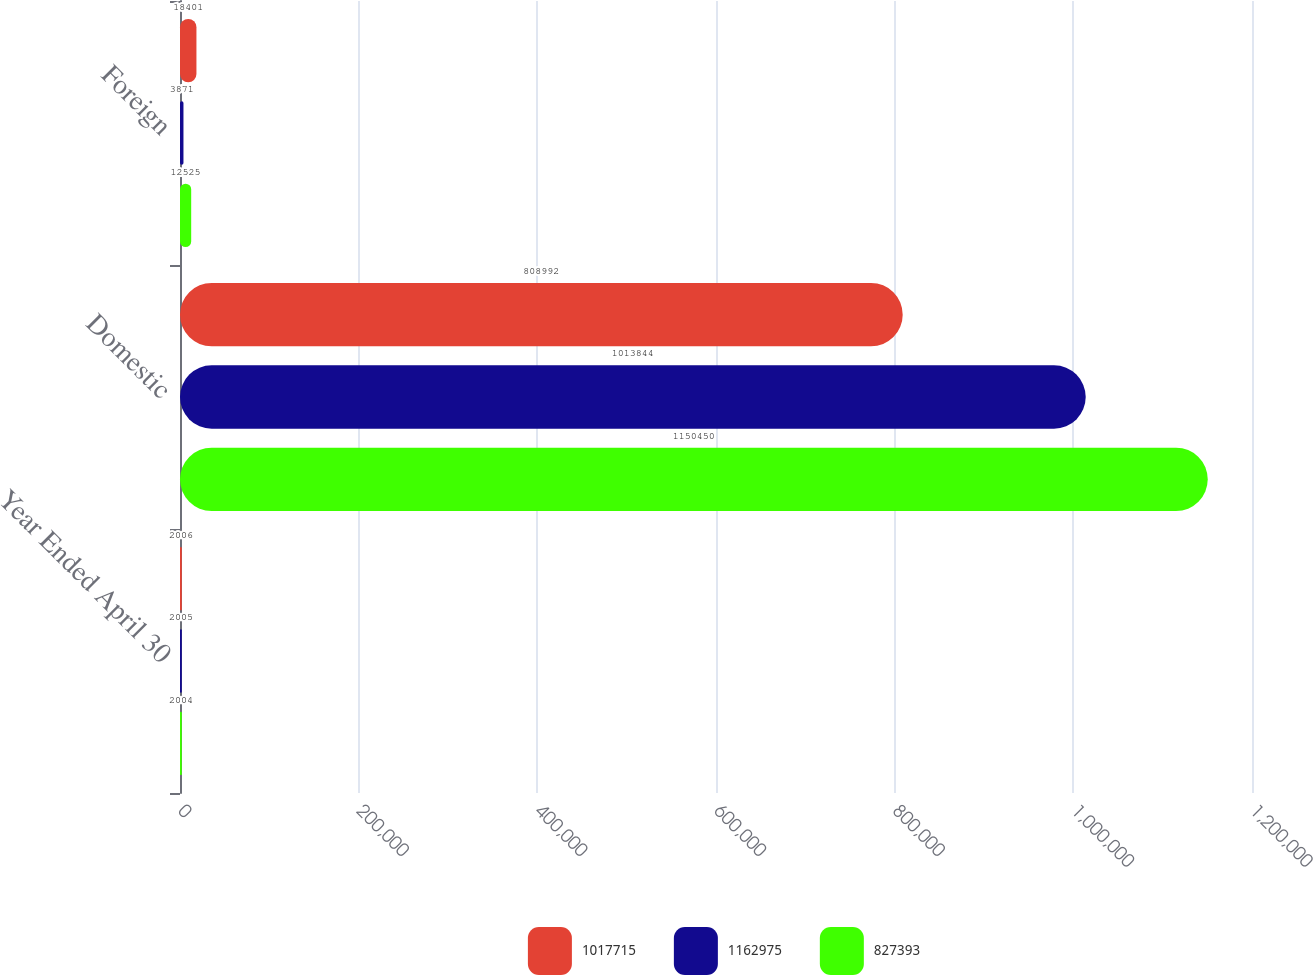Convert chart to OTSL. <chart><loc_0><loc_0><loc_500><loc_500><stacked_bar_chart><ecel><fcel>Year Ended April 30<fcel>Domestic<fcel>Foreign<nl><fcel>1.01772e+06<fcel>2006<fcel>808992<fcel>18401<nl><fcel>1.16298e+06<fcel>2005<fcel>1.01384e+06<fcel>3871<nl><fcel>827393<fcel>2004<fcel>1.15045e+06<fcel>12525<nl></chart> 